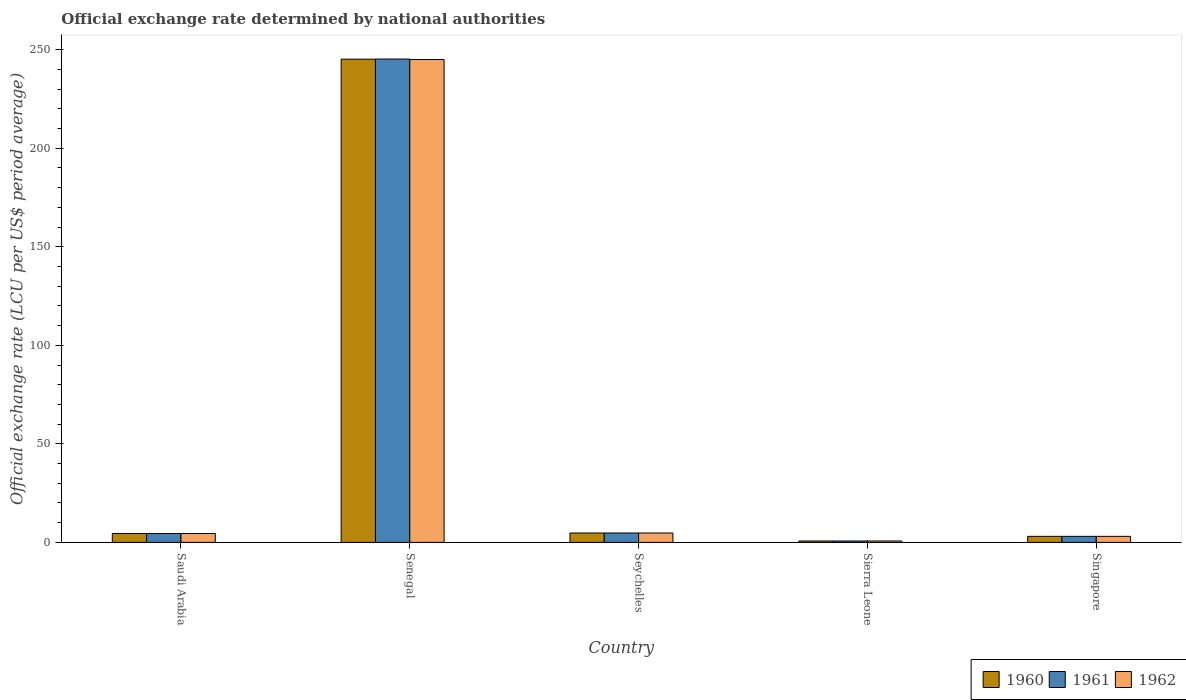How many different coloured bars are there?
Keep it short and to the point. 3. Are the number of bars on each tick of the X-axis equal?
Make the answer very short. Yes. How many bars are there on the 2nd tick from the left?
Ensure brevity in your answer.  3. What is the label of the 1st group of bars from the left?
Ensure brevity in your answer.  Saudi Arabia. What is the official exchange rate in 1962 in Singapore?
Make the answer very short. 3.06. Across all countries, what is the maximum official exchange rate in 1962?
Offer a very short reply. 245.01. Across all countries, what is the minimum official exchange rate in 1960?
Ensure brevity in your answer.  0.71. In which country was the official exchange rate in 1960 maximum?
Give a very brief answer. Senegal. In which country was the official exchange rate in 1960 minimum?
Provide a short and direct response. Sierra Leone. What is the total official exchange rate in 1960 in the graph?
Your answer should be very brief. 258.23. What is the difference between the official exchange rate in 1961 in Saudi Arabia and that in Singapore?
Give a very brief answer. 1.44. What is the difference between the official exchange rate in 1962 in Saudi Arabia and the official exchange rate in 1961 in Sierra Leone?
Your answer should be very brief. 3.79. What is the average official exchange rate in 1961 per country?
Make the answer very short. 51.66. What is the ratio of the official exchange rate in 1962 in Saudi Arabia to that in Seychelles?
Offer a terse response. 0.95. Is the difference between the official exchange rate in 1960 in Saudi Arabia and Senegal greater than the difference between the official exchange rate in 1961 in Saudi Arabia and Senegal?
Give a very brief answer. Yes. What is the difference between the highest and the second highest official exchange rate in 1961?
Keep it short and to the point. -240.5. What is the difference between the highest and the lowest official exchange rate in 1960?
Ensure brevity in your answer.  244.48. Is the sum of the official exchange rate in 1961 in Senegal and Singapore greater than the maximum official exchange rate in 1962 across all countries?
Offer a terse response. Yes. Are all the bars in the graph horizontal?
Your answer should be very brief. No. Are the values on the major ticks of Y-axis written in scientific E-notation?
Provide a succinct answer. No. How many legend labels are there?
Your response must be concise. 3. What is the title of the graph?
Your response must be concise. Official exchange rate determined by national authorities. Does "2009" appear as one of the legend labels in the graph?
Offer a very short reply. No. What is the label or title of the X-axis?
Offer a very short reply. Country. What is the label or title of the Y-axis?
Ensure brevity in your answer.  Official exchange rate (LCU per US$ period average). What is the Official exchange rate (LCU per US$ period average) in 1960 in Saudi Arabia?
Make the answer very short. 4.5. What is the Official exchange rate (LCU per US$ period average) of 1961 in Saudi Arabia?
Offer a terse response. 4.5. What is the Official exchange rate (LCU per US$ period average) of 1962 in Saudi Arabia?
Provide a short and direct response. 4.5. What is the Official exchange rate (LCU per US$ period average) in 1960 in Senegal?
Make the answer very short. 245.2. What is the Official exchange rate (LCU per US$ period average) of 1961 in Senegal?
Give a very brief answer. 245.26. What is the Official exchange rate (LCU per US$ period average) in 1962 in Senegal?
Give a very brief answer. 245.01. What is the Official exchange rate (LCU per US$ period average) of 1960 in Seychelles?
Ensure brevity in your answer.  4.76. What is the Official exchange rate (LCU per US$ period average) of 1961 in Seychelles?
Your response must be concise. 4.76. What is the Official exchange rate (LCU per US$ period average) in 1962 in Seychelles?
Keep it short and to the point. 4.76. What is the Official exchange rate (LCU per US$ period average) of 1960 in Sierra Leone?
Make the answer very short. 0.71. What is the Official exchange rate (LCU per US$ period average) in 1961 in Sierra Leone?
Your response must be concise. 0.71. What is the Official exchange rate (LCU per US$ period average) of 1962 in Sierra Leone?
Make the answer very short. 0.71. What is the Official exchange rate (LCU per US$ period average) in 1960 in Singapore?
Offer a terse response. 3.06. What is the Official exchange rate (LCU per US$ period average) of 1961 in Singapore?
Offer a terse response. 3.06. What is the Official exchange rate (LCU per US$ period average) in 1962 in Singapore?
Your answer should be compact. 3.06. Across all countries, what is the maximum Official exchange rate (LCU per US$ period average) of 1960?
Ensure brevity in your answer.  245.2. Across all countries, what is the maximum Official exchange rate (LCU per US$ period average) of 1961?
Make the answer very short. 245.26. Across all countries, what is the maximum Official exchange rate (LCU per US$ period average) in 1962?
Provide a short and direct response. 245.01. Across all countries, what is the minimum Official exchange rate (LCU per US$ period average) of 1960?
Ensure brevity in your answer.  0.71. Across all countries, what is the minimum Official exchange rate (LCU per US$ period average) in 1961?
Offer a terse response. 0.71. Across all countries, what is the minimum Official exchange rate (LCU per US$ period average) of 1962?
Ensure brevity in your answer.  0.71. What is the total Official exchange rate (LCU per US$ period average) in 1960 in the graph?
Ensure brevity in your answer.  258.23. What is the total Official exchange rate (LCU per US$ period average) in 1961 in the graph?
Provide a succinct answer. 258.3. What is the total Official exchange rate (LCU per US$ period average) in 1962 in the graph?
Make the answer very short. 258.05. What is the difference between the Official exchange rate (LCU per US$ period average) of 1960 in Saudi Arabia and that in Senegal?
Provide a succinct answer. -240.7. What is the difference between the Official exchange rate (LCU per US$ period average) in 1961 in Saudi Arabia and that in Senegal?
Offer a very short reply. -240.76. What is the difference between the Official exchange rate (LCU per US$ period average) in 1962 in Saudi Arabia and that in Senegal?
Your answer should be very brief. -240.51. What is the difference between the Official exchange rate (LCU per US$ period average) in 1960 in Saudi Arabia and that in Seychelles?
Your answer should be very brief. -0.26. What is the difference between the Official exchange rate (LCU per US$ period average) of 1961 in Saudi Arabia and that in Seychelles?
Your response must be concise. -0.26. What is the difference between the Official exchange rate (LCU per US$ period average) in 1962 in Saudi Arabia and that in Seychelles?
Your answer should be compact. -0.26. What is the difference between the Official exchange rate (LCU per US$ period average) in 1960 in Saudi Arabia and that in Sierra Leone?
Make the answer very short. 3.79. What is the difference between the Official exchange rate (LCU per US$ period average) in 1961 in Saudi Arabia and that in Sierra Leone?
Your answer should be compact. 3.79. What is the difference between the Official exchange rate (LCU per US$ period average) of 1962 in Saudi Arabia and that in Sierra Leone?
Give a very brief answer. 3.79. What is the difference between the Official exchange rate (LCU per US$ period average) of 1960 in Saudi Arabia and that in Singapore?
Offer a very short reply. 1.44. What is the difference between the Official exchange rate (LCU per US$ period average) in 1961 in Saudi Arabia and that in Singapore?
Make the answer very short. 1.44. What is the difference between the Official exchange rate (LCU per US$ period average) of 1962 in Saudi Arabia and that in Singapore?
Offer a terse response. 1.44. What is the difference between the Official exchange rate (LCU per US$ period average) of 1960 in Senegal and that in Seychelles?
Ensure brevity in your answer.  240.43. What is the difference between the Official exchange rate (LCU per US$ period average) of 1961 in Senegal and that in Seychelles?
Make the answer very short. 240.5. What is the difference between the Official exchange rate (LCU per US$ period average) of 1962 in Senegal and that in Seychelles?
Provide a succinct answer. 240.25. What is the difference between the Official exchange rate (LCU per US$ period average) in 1960 in Senegal and that in Sierra Leone?
Your answer should be very brief. 244.48. What is the difference between the Official exchange rate (LCU per US$ period average) of 1961 in Senegal and that in Sierra Leone?
Make the answer very short. 244.55. What is the difference between the Official exchange rate (LCU per US$ period average) in 1962 in Senegal and that in Sierra Leone?
Provide a succinct answer. 244.3. What is the difference between the Official exchange rate (LCU per US$ period average) in 1960 in Senegal and that in Singapore?
Make the answer very short. 242.13. What is the difference between the Official exchange rate (LCU per US$ period average) in 1961 in Senegal and that in Singapore?
Keep it short and to the point. 242.2. What is the difference between the Official exchange rate (LCU per US$ period average) in 1962 in Senegal and that in Singapore?
Ensure brevity in your answer.  241.95. What is the difference between the Official exchange rate (LCU per US$ period average) of 1960 in Seychelles and that in Sierra Leone?
Ensure brevity in your answer.  4.05. What is the difference between the Official exchange rate (LCU per US$ period average) of 1961 in Seychelles and that in Sierra Leone?
Your answer should be very brief. 4.05. What is the difference between the Official exchange rate (LCU per US$ period average) of 1962 in Seychelles and that in Sierra Leone?
Ensure brevity in your answer.  4.05. What is the difference between the Official exchange rate (LCU per US$ period average) of 1960 in Seychelles and that in Singapore?
Your answer should be compact. 1.7. What is the difference between the Official exchange rate (LCU per US$ period average) in 1961 in Seychelles and that in Singapore?
Provide a short and direct response. 1.7. What is the difference between the Official exchange rate (LCU per US$ period average) of 1962 in Seychelles and that in Singapore?
Keep it short and to the point. 1.7. What is the difference between the Official exchange rate (LCU per US$ period average) in 1960 in Sierra Leone and that in Singapore?
Offer a terse response. -2.35. What is the difference between the Official exchange rate (LCU per US$ period average) in 1961 in Sierra Leone and that in Singapore?
Your answer should be compact. -2.35. What is the difference between the Official exchange rate (LCU per US$ period average) in 1962 in Sierra Leone and that in Singapore?
Keep it short and to the point. -2.35. What is the difference between the Official exchange rate (LCU per US$ period average) in 1960 in Saudi Arabia and the Official exchange rate (LCU per US$ period average) in 1961 in Senegal?
Offer a terse response. -240.76. What is the difference between the Official exchange rate (LCU per US$ period average) in 1960 in Saudi Arabia and the Official exchange rate (LCU per US$ period average) in 1962 in Senegal?
Provide a succinct answer. -240.51. What is the difference between the Official exchange rate (LCU per US$ period average) in 1961 in Saudi Arabia and the Official exchange rate (LCU per US$ period average) in 1962 in Senegal?
Offer a very short reply. -240.51. What is the difference between the Official exchange rate (LCU per US$ period average) of 1960 in Saudi Arabia and the Official exchange rate (LCU per US$ period average) of 1961 in Seychelles?
Your answer should be very brief. -0.26. What is the difference between the Official exchange rate (LCU per US$ period average) in 1960 in Saudi Arabia and the Official exchange rate (LCU per US$ period average) in 1962 in Seychelles?
Provide a succinct answer. -0.26. What is the difference between the Official exchange rate (LCU per US$ period average) in 1961 in Saudi Arabia and the Official exchange rate (LCU per US$ period average) in 1962 in Seychelles?
Your response must be concise. -0.26. What is the difference between the Official exchange rate (LCU per US$ period average) of 1960 in Saudi Arabia and the Official exchange rate (LCU per US$ period average) of 1961 in Sierra Leone?
Provide a short and direct response. 3.79. What is the difference between the Official exchange rate (LCU per US$ period average) of 1960 in Saudi Arabia and the Official exchange rate (LCU per US$ period average) of 1962 in Sierra Leone?
Offer a very short reply. 3.79. What is the difference between the Official exchange rate (LCU per US$ period average) of 1961 in Saudi Arabia and the Official exchange rate (LCU per US$ period average) of 1962 in Sierra Leone?
Make the answer very short. 3.79. What is the difference between the Official exchange rate (LCU per US$ period average) in 1960 in Saudi Arabia and the Official exchange rate (LCU per US$ period average) in 1961 in Singapore?
Offer a very short reply. 1.44. What is the difference between the Official exchange rate (LCU per US$ period average) of 1960 in Saudi Arabia and the Official exchange rate (LCU per US$ period average) of 1962 in Singapore?
Offer a terse response. 1.44. What is the difference between the Official exchange rate (LCU per US$ period average) in 1961 in Saudi Arabia and the Official exchange rate (LCU per US$ period average) in 1962 in Singapore?
Your response must be concise. 1.44. What is the difference between the Official exchange rate (LCU per US$ period average) in 1960 in Senegal and the Official exchange rate (LCU per US$ period average) in 1961 in Seychelles?
Your answer should be very brief. 240.43. What is the difference between the Official exchange rate (LCU per US$ period average) of 1960 in Senegal and the Official exchange rate (LCU per US$ period average) of 1962 in Seychelles?
Ensure brevity in your answer.  240.43. What is the difference between the Official exchange rate (LCU per US$ period average) in 1961 in Senegal and the Official exchange rate (LCU per US$ period average) in 1962 in Seychelles?
Give a very brief answer. 240.5. What is the difference between the Official exchange rate (LCU per US$ period average) of 1960 in Senegal and the Official exchange rate (LCU per US$ period average) of 1961 in Sierra Leone?
Your answer should be very brief. 244.48. What is the difference between the Official exchange rate (LCU per US$ period average) in 1960 in Senegal and the Official exchange rate (LCU per US$ period average) in 1962 in Sierra Leone?
Provide a succinct answer. 244.48. What is the difference between the Official exchange rate (LCU per US$ period average) in 1961 in Senegal and the Official exchange rate (LCU per US$ period average) in 1962 in Sierra Leone?
Offer a terse response. 244.55. What is the difference between the Official exchange rate (LCU per US$ period average) of 1960 in Senegal and the Official exchange rate (LCU per US$ period average) of 1961 in Singapore?
Give a very brief answer. 242.13. What is the difference between the Official exchange rate (LCU per US$ period average) in 1960 in Senegal and the Official exchange rate (LCU per US$ period average) in 1962 in Singapore?
Give a very brief answer. 242.13. What is the difference between the Official exchange rate (LCU per US$ period average) of 1961 in Senegal and the Official exchange rate (LCU per US$ period average) of 1962 in Singapore?
Your response must be concise. 242.2. What is the difference between the Official exchange rate (LCU per US$ period average) of 1960 in Seychelles and the Official exchange rate (LCU per US$ period average) of 1961 in Sierra Leone?
Ensure brevity in your answer.  4.05. What is the difference between the Official exchange rate (LCU per US$ period average) in 1960 in Seychelles and the Official exchange rate (LCU per US$ period average) in 1962 in Sierra Leone?
Make the answer very short. 4.05. What is the difference between the Official exchange rate (LCU per US$ period average) of 1961 in Seychelles and the Official exchange rate (LCU per US$ period average) of 1962 in Sierra Leone?
Ensure brevity in your answer.  4.05. What is the difference between the Official exchange rate (LCU per US$ period average) of 1960 in Seychelles and the Official exchange rate (LCU per US$ period average) of 1961 in Singapore?
Make the answer very short. 1.7. What is the difference between the Official exchange rate (LCU per US$ period average) in 1960 in Seychelles and the Official exchange rate (LCU per US$ period average) in 1962 in Singapore?
Give a very brief answer. 1.7. What is the difference between the Official exchange rate (LCU per US$ period average) in 1961 in Seychelles and the Official exchange rate (LCU per US$ period average) in 1962 in Singapore?
Your answer should be very brief. 1.7. What is the difference between the Official exchange rate (LCU per US$ period average) in 1960 in Sierra Leone and the Official exchange rate (LCU per US$ period average) in 1961 in Singapore?
Keep it short and to the point. -2.35. What is the difference between the Official exchange rate (LCU per US$ period average) in 1960 in Sierra Leone and the Official exchange rate (LCU per US$ period average) in 1962 in Singapore?
Ensure brevity in your answer.  -2.35. What is the difference between the Official exchange rate (LCU per US$ period average) of 1961 in Sierra Leone and the Official exchange rate (LCU per US$ period average) of 1962 in Singapore?
Provide a short and direct response. -2.35. What is the average Official exchange rate (LCU per US$ period average) of 1960 per country?
Offer a terse response. 51.65. What is the average Official exchange rate (LCU per US$ period average) of 1961 per country?
Make the answer very short. 51.66. What is the average Official exchange rate (LCU per US$ period average) of 1962 per country?
Offer a very short reply. 51.61. What is the difference between the Official exchange rate (LCU per US$ period average) of 1960 and Official exchange rate (LCU per US$ period average) of 1962 in Saudi Arabia?
Your answer should be very brief. 0. What is the difference between the Official exchange rate (LCU per US$ period average) in 1960 and Official exchange rate (LCU per US$ period average) in 1961 in Senegal?
Provide a succinct answer. -0.07. What is the difference between the Official exchange rate (LCU per US$ period average) in 1960 and Official exchange rate (LCU per US$ period average) in 1962 in Senegal?
Keep it short and to the point. 0.18. What is the difference between the Official exchange rate (LCU per US$ period average) of 1961 and Official exchange rate (LCU per US$ period average) of 1962 in Senegal?
Provide a short and direct response. 0.25. What is the difference between the Official exchange rate (LCU per US$ period average) in 1960 and Official exchange rate (LCU per US$ period average) in 1962 in Seychelles?
Keep it short and to the point. 0. What is the difference between the Official exchange rate (LCU per US$ period average) of 1961 and Official exchange rate (LCU per US$ period average) of 1962 in Seychelles?
Ensure brevity in your answer.  0. What is the difference between the Official exchange rate (LCU per US$ period average) in 1960 and Official exchange rate (LCU per US$ period average) in 1961 in Sierra Leone?
Keep it short and to the point. 0. What is the difference between the Official exchange rate (LCU per US$ period average) in 1960 and Official exchange rate (LCU per US$ period average) in 1962 in Sierra Leone?
Your answer should be very brief. 0. What is the difference between the Official exchange rate (LCU per US$ period average) in 1961 and Official exchange rate (LCU per US$ period average) in 1962 in Sierra Leone?
Make the answer very short. 0. What is the difference between the Official exchange rate (LCU per US$ period average) of 1960 and Official exchange rate (LCU per US$ period average) of 1961 in Singapore?
Provide a succinct answer. 0. What is the difference between the Official exchange rate (LCU per US$ period average) in 1960 and Official exchange rate (LCU per US$ period average) in 1962 in Singapore?
Your answer should be very brief. 0. What is the difference between the Official exchange rate (LCU per US$ period average) of 1961 and Official exchange rate (LCU per US$ period average) of 1962 in Singapore?
Give a very brief answer. 0. What is the ratio of the Official exchange rate (LCU per US$ period average) in 1960 in Saudi Arabia to that in Senegal?
Provide a succinct answer. 0.02. What is the ratio of the Official exchange rate (LCU per US$ period average) in 1961 in Saudi Arabia to that in Senegal?
Offer a terse response. 0.02. What is the ratio of the Official exchange rate (LCU per US$ period average) of 1962 in Saudi Arabia to that in Senegal?
Offer a terse response. 0.02. What is the ratio of the Official exchange rate (LCU per US$ period average) of 1960 in Saudi Arabia to that in Seychelles?
Offer a terse response. 0.94. What is the ratio of the Official exchange rate (LCU per US$ period average) in 1961 in Saudi Arabia to that in Seychelles?
Give a very brief answer. 0.94. What is the ratio of the Official exchange rate (LCU per US$ period average) in 1962 in Saudi Arabia to that in Seychelles?
Your answer should be very brief. 0.94. What is the ratio of the Official exchange rate (LCU per US$ period average) of 1962 in Saudi Arabia to that in Sierra Leone?
Ensure brevity in your answer.  6.3. What is the ratio of the Official exchange rate (LCU per US$ period average) in 1960 in Saudi Arabia to that in Singapore?
Provide a succinct answer. 1.47. What is the ratio of the Official exchange rate (LCU per US$ period average) in 1961 in Saudi Arabia to that in Singapore?
Your response must be concise. 1.47. What is the ratio of the Official exchange rate (LCU per US$ period average) in 1962 in Saudi Arabia to that in Singapore?
Provide a short and direct response. 1.47. What is the ratio of the Official exchange rate (LCU per US$ period average) of 1960 in Senegal to that in Seychelles?
Keep it short and to the point. 51.49. What is the ratio of the Official exchange rate (LCU per US$ period average) in 1961 in Senegal to that in Seychelles?
Offer a very short reply. 51.5. What is the ratio of the Official exchange rate (LCU per US$ period average) of 1962 in Senegal to that in Seychelles?
Offer a terse response. 51.45. What is the ratio of the Official exchange rate (LCU per US$ period average) in 1960 in Senegal to that in Sierra Leone?
Provide a succinct answer. 343.27. What is the ratio of the Official exchange rate (LCU per US$ period average) in 1961 in Senegal to that in Sierra Leone?
Ensure brevity in your answer.  343.36. What is the ratio of the Official exchange rate (LCU per US$ period average) of 1962 in Senegal to that in Sierra Leone?
Provide a short and direct response. 343.02. What is the ratio of the Official exchange rate (LCU per US$ period average) in 1960 in Senegal to that in Singapore?
Offer a very short reply. 80.1. What is the ratio of the Official exchange rate (LCU per US$ period average) of 1961 in Senegal to that in Singapore?
Your answer should be compact. 80.12. What is the ratio of the Official exchange rate (LCU per US$ period average) in 1962 in Senegal to that in Singapore?
Provide a short and direct response. 80.04. What is the ratio of the Official exchange rate (LCU per US$ period average) of 1960 in Seychelles to that in Sierra Leone?
Provide a succinct answer. 6.67. What is the ratio of the Official exchange rate (LCU per US$ period average) in 1961 in Seychelles to that in Sierra Leone?
Keep it short and to the point. 6.67. What is the ratio of the Official exchange rate (LCU per US$ period average) in 1962 in Seychelles to that in Sierra Leone?
Make the answer very short. 6.67. What is the ratio of the Official exchange rate (LCU per US$ period average) of 1960 in Seychelles to that in Singapore?
Your answer should be very brief. 1.56. What is the ratio of the Official exchange rate (LCU per US$ period average) of 1961 in Seychelles to that in Singapore?
Offer a very short reply. 1.56. What is the ratio of the Official exchange rate (LCU per US$ period average) in 1962 in Seychelles to that in Singapore?
Your answer should be very brief. 1.56. What is the ratio of the Official exchange rate (LCU per US$ period average) in 1960 in Sierra Leone to that in Singapore?
Offer a terse response. 0.23. What is the ratio of the Official exchange rate (LCU per US$ period average) in 1961 in Sierra Leone to that in Singapore?
Your answer should be compact. 0.23. What is the ratio of the Official exchange rate (LCU per US$ period average) in 1962 in Sierra Leone to that in Singapore?
Your response must be concise. 0.23. What is the difference between the highest and the second highest Official exchange rate (LCU per US$ period average) in 1960?
Ensure brevity in your answer.  240.43. What is the difference between the highest and the second highest Official exchange rate (LCU per US$ period average) of 1961?
Keep it short and to the point. 240.5. What is the difference between the highest and the second highest Official exchange rate (LCU per US$ period average) in 1962?
Your answer should be compact. 240.25. What is the difference between the highest and the lowest Official exchange rate (LCU per US$ period average) in 1960?
Your response must be concise. 244.48. What is the difference between the highest and the lowest Official exchange rate (LCU per US$ period average) of 1961?
Ensure brevity in your answer.  244.55. What is the difference between the highest and the lowest Official exchange rate (LCU per US$ period average) of 1962?
Your answer should be very brief. 244.3. 